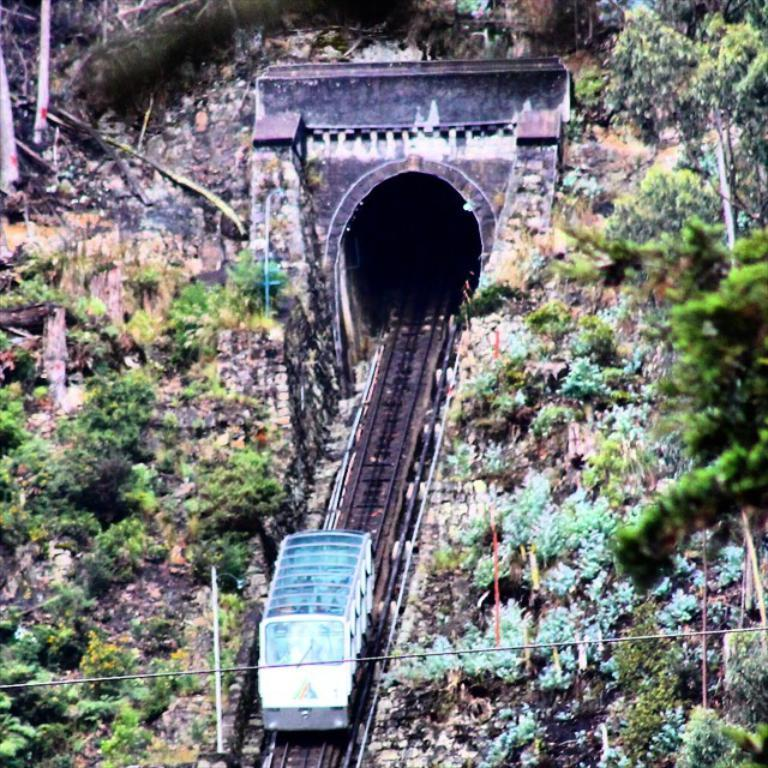What is the main subject of the image? The main subject of the image is a train. What can be seen in the background of the image? The railway track, a tunnel, trees, and plants are visible in the background of the image. Are there any additional structures or objects in the image? Yes, there is a wire and a white colored object present in the image. What is the price of the fowl in the image? There is no fowl present in the image, so it is not possible to determine its price. What type of tray is being used to serve the white colored object in the image? There is no tray present in the image; only the white colored object is mentioned. 